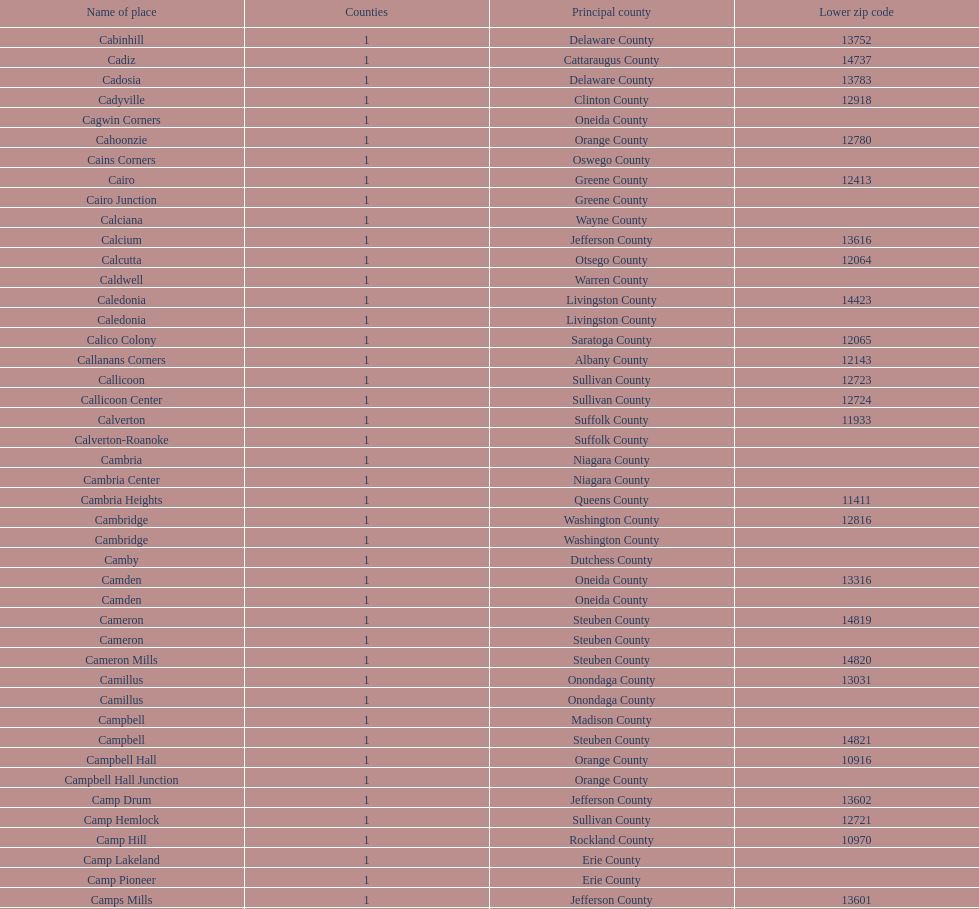How many sites can be found in greene county? 10. 